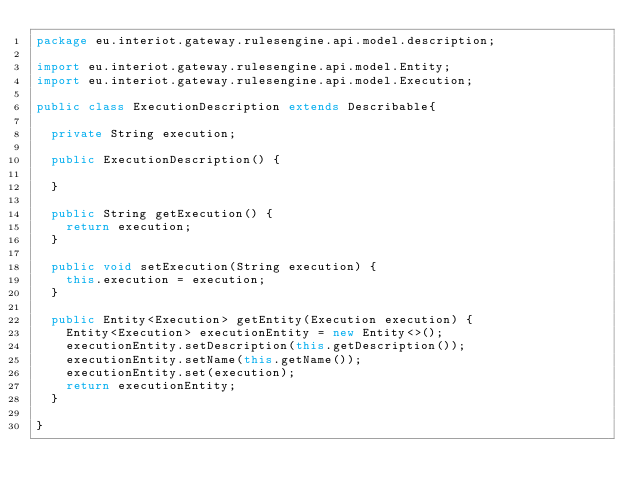Convert code to text. <code><loc_0><loc_0><loc_500><loc_500><_Java_>package eu.interiot.gateway.rulesengine.api.model.description;

import eu.interiot.gateway.rulesengine.api.model.Entity;
import eu.interiot.gateway.rulesengine.api.model.Execution;

public class ExecutionDescription extends Describable{
	
	private String execution;
	
	public ExecutionDescription() {
		
	}

	public String getExecution() {
		return execution;
	}

	public void setExecution(String execution) {
		this.execution = execution;
	}
	
	public Entity<Execution> getEntity(Execution execution) {
		Entity<Execution> executionEntity = new Entity<>();
		executionEntity.setDescription(this.getDescription());
		executionEntity.setName(this.getName());
		executionEntity.set(execution);
		return executionEntity;
	}
	
}
</code> 